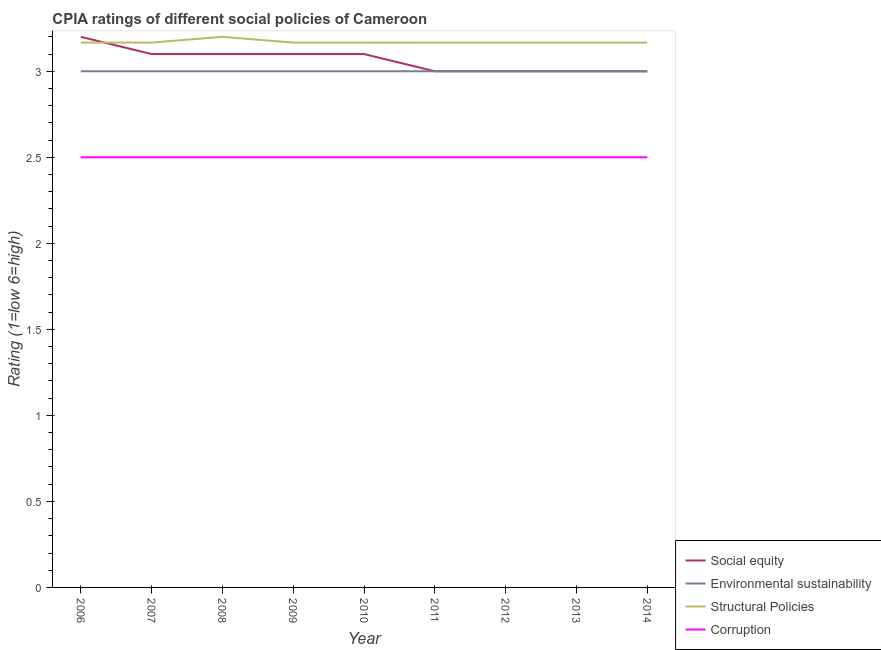How many different coloured lines are there?
Offer a very short reply. 4. Does the line corresponding to cpia rating of structural policies intersect with the line corresponding to cpia rating of environmental sustainability?
Ensure brevity in your answer.  No. What is the cpia rating of environmental sustainability in 2008?
Your response must be concise. 3. Across all years, what is the minimum cpia rating of environmental sustainability?
Your response must be concise. 3. In which year was the cpia rating of environmental sustainability minimum?
Provide a short and direct response. 2006. What is the difference between the cpia rating of environmental sustainability in 2006 and that in 2013?
Ensure brevity in your answer.  0. What is the difference between the cpia rating of social equity in 2014 and the cpia rating of environmental sustainability in 2013?
Provide a short and direct response. 0. What is the average cpia rating of social equity per year?
Your answer should be very brief. 3.07. In the year 2012, what is the difference between the cpia rating of environmental sustainability and cpia rating of corruption?
Provide a succinct answer. 0.5. What is the ratio of the cpia rating of corruption in 2007 to that in 2009?
Provide a short and direct response. 1. Is the difference between the cpia rating of environmental sustainability in 2008 and 2012 greater than the difference between the cpia rating of social equity in 2008 and 2012?
Make the answer very short. No. In how many years, is the cpia rating of environmental sustainability greater than the average cpia rating of environmental sustainability taken over all years?
Keep it short and to the point. 0. Is the sum of the cpia rating of structural policies in 2007 and 2008 greater than the maximum cpia rating of corruption across all years?
Ensure brevity in your answer.  Yes. Is it the case that in every year, the sum of the cpia rating of structural policies and cpia rating of environmental sustainability is greater than the sum of cpia rating of corruption and cpia rating of social equity?
Make the answer very short. Yes. Is it the case that in every year, the sum of the cpia rating of social equity and cpia rating of environmental sustainability is greater than the cpia rating of structural policies?
Make the answer very short. Yes. Does the cpia rating of corruption monotonically increase over the years?
Give a very brief answer. No. Is the cpia rating of environmental sustainability strictly greater than the cpia rating of structural policies over the years?
Your answer should be very brief. No. How many lines are there?
Your response must be concise. 4. Does the graph contain grids?
Your answer should be compact. No. Where does the legend appear in the graph?
Provide a succinct answer. Bottom right. What is the title of the graph?
Your response must be concise. CPIA ratings of different social policies of Cameroon. Does "Forest" appear as one of the legend labels in the graph?
Provide a short and direct response. No. What is the Rating (1=low 6=high) in Environmental sustainability in 2006?
Keep it short and to the point. 3. What is the Rating (1=low 6=high) in Structural Policies in 2006?
Give a very brief answer. 3.17. What is the Rating (1=low 6=high) in Corruption in 2006?
Make the answer very short. 2.5. What is the Rating (1=low 6=high) in Environmental sustainability in 2007?
Give a very brief answer. 3. What is the Rating (1=low 6=high) in Structural Policies in 2007?
Your response must be concise. 3.17. What is the Rating (1=low 6=high) in Corruption in 2007?
Make the answer very short. 2.5. What is the Rating (1=low 6=high) of Social equity in 2008?
Ensure brevity in your answer.  3.1. What is the Rating (1=low 6=high) in Corruption in 2008?
Your answer should be compact. 2.5. What is the Rating (1=low 6=high) in Social equity in 2009?
Give a very brief answer. 3.1. What is the Rating (1=low 6=high) of Structural Policies in 2009?
Keep it short and to the point. 3.17. What is the Rating (1=low 6=high) of Structural Policies in 2010?
Make the answer very short. 3.17. What is the Rating (1=low 6=high) of Structural Policies in 2011?
Offer a terse response. 3.17. What is the Rating (1=low 6=high) in Environmental sustainability in 2012?
Ensure brevity in your answer.  3. What is the Rating (1=low 6=high) of Structural Policies in 2012?
Make the answer very short. 3.17. What is the Rating (1=low 6=high) of Corruption in 2012?
Your answer should be very brief. 2.5. What is the Rating (1=low 6=high) of Social equity in 2013?
Provide a short and direct response. 3. What is the Rating (1=low 6=high) in Structural Policies in 2013?
Provide a short and direct response. 3.17. What is the Rating (1=low 6=high) in Corruption in 2013?
Make the answer very short. 2.5. What is the Rating (1=low 6=high) in Social equity in 2014?
Offer a very short reply. 3. What is the Rating (1=low 6=high) of Structural Policies in 2014?
Provide a short and direct response. 3.17. What is the Rating (1=low 6=high) in Corruption in 2014?
Give a very brief answer. 2.5. Across all years, what is the maximum Rating (1=low 6=high) in Environmental sustainability?
Offer a terse response. 3. Across all years, what is the minimum Rating (1=low 6=high) in Social equity?
Your answer should be very brief. 3. Across all years, what is the minimum Rating (1=low 6=high) in Environmental sustainability?
Your answer should be very brief. 3. Across all years, what is the minimum Rating (1=low 6=high) in Structural Policies?
Provide a short and direct response. 3.17. Across all years, what is the minimum Rating (1=low 6=high) of Corruption?
Make the answer very short. 2.5. What is the total Rating (1=low 6=high) of Social equity in the graph?
Ensure brevity in your answer.  27.6. What is the total Rating (1=low 6=high) in Structural Policies in the graph?
Ensure brevity in your answer.  28.53. What is the total Rating (1=low 6=high) of Corruption in the graph?
Your answer should be very brief. 22.5. What is the difference between the Rating (1=low 6=high) in Corruption in 2006 and that in 2007?
Offer a terse response. 0. What is the difference between the Rating (1=low 6=high) in Structural Policies in 2006 and that in 2008?
Provide a short and direct response. -0.03. What is the difference between the Rating (1=low 6=high) in Corruption in 2006 and that in 2008?
Ensure brevity in your answer.  0. What is the difference between the Rating (1=low 6=high) in Social equity in 2006 and that in 2009?
Your answer should be very brief. 0.1. What is the difference between the Rating (1=low 6=high) in Environmental sustainability in 2006 and that in 2009?
Offer a terse response. 0. What is the difference between the Rating (1=low 6=high) in Structural Policies in 2006 and that in 2009?
Give a very brief answer. 0. What is the difference between the Rating (1=low 6=high) in Structural Policies in 2006 and that in 2010?
Offer a very short reply. 0. What is the difference between the Rating (1=low 6=high) of Corruption in 2006 and that in 2011?
Provide a short and direct response. 0. What is the difference between the Rating (1=low 6=high) of Structural Policies in 2006 and that in 2012?
Offer a terse response. 0. What is the difference between the Rating (1=low 6=high) in Social equity in 2006 and that in 2013?
Offer a very short reply. 0.2. What is the difference between the Rating (1=low 6=high) in Structural Policies in 2006 and that in 2013?
Your answer should be compact. 0. What is the difference between the Rating (1=low 6=high) of Environmental sustainability in 2006 and that in 2014?
Offer a terse response. 0. What is the difference between the Rating (1=low 6=high) in Structural Policies in 2006 and that in 2014?
Your response must be concise. 0. What is the difference between the Rating (1=low 6=high) of Corruption in 2006 and that in 2014?
Provide a succinct answer. 0. What is the difference between the Rating (1=low 6=high) of Social equity in 2007 and that in 2008?
Provide a short and direct response. 0. What is the difference between the Rating (1=low 6=high) in Structural Policies in 2007 and that in 2008?
Give a very brief answer. -0.03. What is the difference between the Rating (1=low 6=high) in Corruption in 2007 and that in 2008?
Your answer should be compact. 0. What is the difference between the Rating (1=low 6=high) in Social equity in 2007 and that in 2009?
Provide a succinct answer. 0. What is the difference between the Rating (1=low 6=high) of Corruption in 2007 and that in 2009?
Your answer should be compact. 0. What is the difference between the Rating (1=low 6=high) of Social equity in 2007 and that in 2010?
Provide a succinct answer. 0. What is the difference between the Rating (1=low 6=high) of Structural Policies in 2007 and that in 2011?
Your answer should be very brief. 0. What is the difference between the Rating (1=low 6=high) of Corruption in 2007 and that in 2011?
Offer a terse response. 0. What is the difference between the Rating (1=low 6=high) in Social equity in 2007 and that in 2012?
Make the answer very short. 0.1. What is the difference between the Rating (1=low 6=high) of Environmental sustainability in 2007 and that in 2012?
Make the answer very short. 0. What is the difference between the Rating (1=low 6=high) of Corruption in 2007 and that in 2012?
Provide a short and direct response. 0. What is the difference between the Rating (1=low 6=high) in Social equity in 2007 and that in 2013?
Ensure brevity in your answer.  0.1. What is the difference between the Rating (1=low 6=high) in Environmental sustainability in 2007 and that in 2013?
Your answer should be compact. 0. What is the difference between the Rating (1=low 6=high) in Corruption in 2007 and that in 2013?
Keep it short and to the point. 0. What is the difference between the Rating (1=low 6=high) of Environmental sustainability in 2007 and that in 2014?
Provide a succinct answer. 0. What is the difference between the Rating (1=low 6=high) of Social equity in 2008 and that in 2009?
Keep it short and to the point. 0. What is the difference between the Rating (1=low 6=high) of Structural Policies in 2008 and that in 2009?
Offer a terse response. 0.03. What is the difference between the Rating (1=low 6=high) of Corruption in 2008 and that in 2010?
Your answer should be compact. 0. What is the difference between the Rating (1=low 6=high) in Environmental sustainability in 2008 and that in 2011?
Provide a succinct answer. 0. What is the difference between the Rating (1=low 6=high) of Social equity in 2008 and that in 2012?
Provide a short and direct response. 0.1. What is the difference between the Rating (1=low 6=high) of Environmental sustainability in 2008 and that in 2012?
Make the answer very short. 0. What is the difference between the Rating (1=low 6=high) in Corruption in 2008 and that in 2012?
Give a very brief answer. 0. What is the difference between the Rating (1=low 6=high) in Social equity in 2008 and that in 2013?
Your answer should be very brief. 0.1. What is the difference between the Rating (1=low 6=high) of Environmental sustainability in 2008 and that in 2013?
Ensure brevity in your answer.  0. What is the difference between the Rating (1=low 6=high) of Structural Policies in 2008 and that in 2013?
Give a very brief answer. 0.03. What is the difference between the Rating (1=low 6=high) of Environmental sustainability in 2008 and that in 2014?
Your answer should be compact. 0. What is the difference between the Rating (1=low 6=high) of Structural Policies in 2008 and that in 2014?
Your response must be concise. 0.03. What is the difference between the Rating (1=low 6=high) in Corruption in 2008 and that in 2014?
Your response must be concise. 0. What is the difference between the Rating (1=low 6=high) in Social equity in 2009 and that in 2010?
Your answer should be very brief. 0. What is the difference between the Rating (1=low 6=high) of Environmental sustainability in 2009 and that in 2010?
Ensure brevity in your answer.  0. What is the difference between the Rating (1=low 6=high) of Corruption in 2009 and that in 2010?
Provide a short and direct response. 0. What is the difference between the Rating (1=low 6=high) of Environmental sustainability in 2009 and that in 2011?
Your answer should be very brief. 0. What is the difference between the Rating (1=low 6=high) in Structural Policies in 2009 and that in 2011?
Give a very brief answer. 0. What is the difference between the Rating (1=low 6=high) in Corruption in 2009 and that in 2011?
Provide a succinct answer. 0. What is the difference between the Rating (1=low 6=high) of Environmental sustainability in 2009 and that in 2012?
Give a very brief answer. 0. What is the difference between the Rating (1=low 6=high) of Environmental sustainability in 2009 and that in 2013?
Provide a succinct answer. 0. What is the difference between the Rating (1=low 6=high) of Structural Policies in 2009 and that in 2013?
Offer a terse response. 0. What is the difference between the Rating (1=low 6=high) in Social equity in 2009 and that in 2014?
Make the answer very short. 0.1. What is the difference between the Rating (1=low 6=high) of Environmental sustainability in 2009 and that in 2014?
Make the answer very short. 0. What is the difference between the Rating (1=low 6=high) of Structural Policies in 2009 and that in 2014?
Provide a short and direct response. 0. What is the difference between the Rating (1=low 6=high) of Structural Policies in 2010 and that in 2011?
Offer a very short reply. 0. What is the difference between the Rating (1=low 6=high) in Social equity in 2010 and that in 2012?
Offer a terse response. 0.1. What is the difference between the Rating (1=low 6=high) in Environmental sustainability in 2010 and that in 2012?
Your answer should be very brief. 0. What is the difference between the Rating (1=low 6=high) of Structural Policies in 2010 and that in 2012?
Your answer should be very brief. 0. What is the difference between the Rating (1=low 6=high) in Corruption in 2010 and that in 2012?
Offer a very short reply. 0. What is the difference between the Rating (1=low 6=high) of Environmental sustainability in 2010 and that in 2013?
Make the answer very short. 0. What is the difference between the Rating (1=low 6=high) in Structural Policies in 2010 and that in 2013?
Offer a terse response. 0. What is the difference between the Rating (1=low 6=high) of Social equity in 2010 and that in 2014?
Ensure brevity in your answer.  0.1. What is the difference between the Rating (1=low 6=high) of Environmental sustainability in 2010 and that in 2014?
Provide a short and direct response. 0. What is the difference between the Rating (1=low 6=high) in Structural Policies in 2010 and that in 2014?
Offer a very short reply. 0. What is the difference between the Rating (1=low 6=high) of Corruption in 2010 and that in 2014?
Offer a very short reply. 0. What is the difference between the Rating (1=low 6=high) of Social equity in 2011 and that in 2012?
Keep it short and to the point. 0. What is the difference between the Rating (1=low 6=high) of Environmental sustainability in 2011 and that in 2012?
Your answer should be very brief. 0. What is the difference between the Rating (1=low 6=high) of Structural Policies in 2011 and that in 2012?
Offer a very short reply. 0. What is the difference between the Rating (1=low 6=high) in Environmental sustainability in 2011 and that in 2013?
Provide a succinct answer. 0. What is the difference between the Rating (1=low 6=high) of Corruption in 2011 and that in 2013?
Keep it short and to the point. 0. What is the difference between the Rating (1=low 6=high) of Environmental sustainability in 2011 and that in 2014?
Your answer should be very brief. 0. What is the difference between the Rating (1=low 6=high) in Corruption in 2011 and that in 2014?
Offer a terse response. 0. What is the difference between the Rating (1=low 6=high) in Environmental sustainability in 2012 and that in 2013?
Ensure brevity in your answer.  0. What is the difference between the Rating (1=low 6=high) of Corruption in 2012 and that in 2013?
Make the answer very short. 0. What is the difference between the Rating (1=low 6=high) of Social equity in 2012 and that in 2014?
Ensure brevity in your answer.  0. What is the difference between the Rating (1=low 6=high) of Structural Policies in 2012 and that in 2014?
Ensure brevity in your answer.  0. What is the difference between the Rating (1=low 6=high) in Corruption in 2012 and that in 2014?
Your response must be concise. 0. What is the difference between the Rating (1=low 6=high) of Social equity in 2013 and that in 2014?
Provide a succinct answer. 0. What is the difference between the Rating (1=low 6=high) of Environmental sustainability in 2013 and that in 2014?
Your answer should be very brief. 0. What is the difference between the Rating (1=low 6=high) in Structural Policies in 2013 and that in 2014?
Ensure brevity in your answer.  0. What is the difference between the Rating (1=low 6=high) of Environmental sustainability in 2006 and the Rating (1=low 6=high) of Structural Policies in 2007?
Offer a very short reply. -0.17. What is the difference between the Rating (1=low 6=high) of Environmental sustainability in 2006 and the Rating (1=low 6=high) of Corruption in 2007?
Ensure brevity in your answer.  0.5. What is the difference between the Rating (1=low 6=high) of Structural Policies in 2006 and the Rating (1=low 6=high) of Corruption in 2007?
Ensure brevity in your answer.  0.67. What is the difference between the Rating (1=low 6=high) of Social equity in 2006 and the Rating (1=low 6=high) of Environmental sustainability in 2008?
Make the answer very short. 0.2. What is the difference between the Rating (1=low 6=high) of Environmental sustainability in 2006 and the Rating (1=low 6=high) of Structural Policies in 2008?
Provide a succinct answer. -0.2. What is the difference between the Rating (1=low 6=high) of Environmental sustainability in 2006 and the Rating (1=low 6=high) of Corruption in 2008?
Make the answer very short. 0.5. What is the difference between the Rating (1=low 6=high) in Structural Policies in 2006 and the Rating (1=low 6=high) in Corruption in 2008?
Provide a succinct answer. 0.67. What is the difference between the Rating (1=low 6=high) of Social equity in 2006 and the Rating (1=low 6=high) of Environmental sustainability in 2009?
Offer a terse response. 0.2. What is the difference between the Rating (1=low 6=high) of Social equity in 2006 and the Rating (1=low 6=high) of Structural Policies in 2009?
Your answer should be compact. 0.03. What is the difference between the Rating (1=low 6=high) of Social equity in 2006 and the Rating (1=low 6=high) of Corruption in 2009?
Give a very brief answer. 0.7. What is the difference between the Rating (1=low 6=high) in Environmental sustainability in 2006 and the Rating (1=low 6=high) in Corruption in 2009?
Make the answer very short. 0.5. What is the difference between the Rating (1=low 6=high) of Social equity in 2006 and the Rating (1=low 6=high) of Environmental sustainability in 2010?
Your response must be concise. 0.2. What is the difference between the Rating (1=low 6=high) in Environmental sustainability in 2006 and the Rating (1=low 6=high) in Structural Policies in 2010?
Provide a succinct answer. -0.17. What is the difference between the Rating (1=low 6=high) of Environmental sustainability in 2006 and the Rating (1=low 6=high) of Corruption in 2010?
Provide a short and direct response. 0.5. What is the difference between the Rating (1=low 6=high) in Structural Policies in 2006 and the Rating (1=low 6=high) in Corruption in 2010?
Your answer should be very brief. 0.67. What is the difference between the Rating (1=low 6=high) of Social equity in 2006 and the Rating (1=low 6=high) of Structural Policies in 2011?
Keep it short and to the point. 0.03. What is the difference between the Rating (1=low 6=high) in Social equity in 2006 and the Rating (1=low 6=high) in Corruption in 2011?
Ensure brevity in your answer.  0.7. What is the difference between the Rating (1=low 6=high) in Environmental sustainability in 2006 and the Rating (1=low 6=high) in Structural Policies in 2011?
Ensure brevity in your answer.  -0.17. What is the difference between the Rating (1=low 6=high) of Environmental sustainability in 2006 and the Rating (1=low 6=high) of Corruption in 2011?
Make the answer very short. 0.5. What is the difference between the Rating (1=low 6=high) of Social equity in 2006 and the Rating (1=low 6=high) of Environmental sustainability in 2012?
Make the answer very short. 0.2. What is the difference between the Rating (1=low 6=high) in Social equity in 2006 and the Rating (1=low 6=high) in Structural Policies in 2012?
Make the answer very short. 0.03. What is the difference between the Rating (1=low 6=high) in Social equity in 2006 and the Rating (1=low 6=high) in Corruption in 2012?
Ensure brevity in your answer.  0.7. What is the difference between the Rating (1=low 6=high) of Environmental sustainability in 2006 and the Rating (1=low 6=high) of Structural Policies in 2012?
Give a very brief answer. -0.17. What is the difference between the Rating (1=low 6=high) of Structural Policies in 2006 and the Rating (1=low 6=high) of Corruption in 2012?
Provide a short and direct response. 0.67. What is the difference between the Rating (1=low 6=high) of Environmental sustainability in 2006 and the Rating (1=low 6=high) of Corruption in 2014?
Ensure brevity in your answer.  0.5. What is the difference between the Rating (1=low 6=high) in Structural Policies in 2006 and the Rating (1=low 6=high) in Corruption in 2014?
Your answer should be compact. 0.67. What is the difference between the Rating (1=low 6=high) in Social equity in 2007 and the Rating (1=low 6=high) in Environmental sustainability in 2008?
Your answer should be compact. 0.1. What is the difference between the Rating (1=low 6=high) in Social equity in 2007 and the Rating (1=low 6=high) in Corruption in 2008?
Your response must be concise. 0.6. What is the difference between the Rating (1=low 6=high) of Environmental sustainability in 2007 and the Rating (1=low 6=high) of Structural Policies in 2008?
Your answer should be compact. -0.2. What is the difference between the Rating (1=low 6=high) of Social equity in 2007 and the Rating (1=low 6=high) of Structural Policies in 2009?
Your answer should be very brief. -0.07. What is the difference between the Rating (1=low 6=high) in Environmental sustainability in 2007 and the Rating (1=low 6=high) in Structural Policies in 2009?
Give a very brief answer. -0.17. What is the difference between the Rating (1=low 6=high) of Environmental sustainability in 2007 and the Rating (1=low 6=high) of Corruption in 2009?
Your answer should be very brief. 0.5. What is the difference between the Rating (1=low 6=high) in Social equity in 2007 and the Rating (1=low 6=high) in Structural Policies in 2010?
Provide a short and direct response. -0.07. What is the difference between the Rating (1=low 6=high) in Structural Policies in 2007 and the Rating (1=low 6=high) in Corruption in 2010?
Offer a terse response. 0.67. What is the difference between the Rating (1=low 6=high) in Social equity in 2007 and the Rating (1=low 6=high) in Structural Policies in 2011?
Provide a succinct answer. -0.07. What is the difference between the Rating (1=low 6=high) of Social equity in 2007 and the Rating (1=low 6=high) of Corruption in 2011?
Offer a terse response. 0.6. What is the difference between the Rating (1=low 6=high) of Environmental sustainability in 2007 and the Rating (1=low 6=high) of Corruption in 2011?
Your response must be concise. 0.5. What is the difference between the Rating (1=low 6=high) of Social equity in 2007 and the Rating (1=low 6=high) of Structural Policies in 2012?
Provide a succinct answer. -0.07. What is the difference between the Rating (1=low 6=high) in Structural Policies in 2007 and the Rating (1=low 6=high) in Corruption in 2012?
Keep it short and to the point. 0.67. What is the difference between the Rating (1=low 6=high) in Social equity in 2007 and the Rating (1=low 6=high) in Structural Policies in 2013?
Keep it short and to the point. -0.07. What is the difference between the Rating (1=low 6=high) in Environmental sustainability in 2007 and the Rating (1=low 6=high) in Structural Policies in 2013?
Ensure brevity in your answer.  -0.17. What is the difference between the Rating (1=low 6=high) of Environmental sustainability in 2007 and the Rating (1=low 6=high) of Corruption in 2013?
Offer a terse response. 0.5. What is the difference between the Rating (1=low 6=high) in Social equity in 2007 and the Rating (1=low 6=high) in Environmental sustainability in 2014?
Ensure brevity in your answer.  0.1. What is the difference between the Rating (1=low 6=high) of Social equity in 2007 and the Rating (1=low 6=high) of Structural Policies in 2014?
Offer a terse response. -0.07. What is the difference between the Rating (1=low 6=high) in Social equity in 2007 and the Rating (1=low 6=high) in Corruption in 2014?
Provide a succinct answer. 0.6. What is the difference between the Rating (1=low 6=high) of Environmental sustainability in 2007 and the Rating (1=low 6=high) of Structural Policies in 2014?
Keep it short and to the point. -0.17. What is the difference between the Rating (1=low 6=high) of Environmental sustainability in 2007 and the Rating (1=low 6=high) of Corruption in 2014?
Your answer should be compact. 0.5. What is the difference between the Rating (1=low 6=high) of Social equity in 2008 and the Rating (1=low 6=high) of Structural Policies in 2009?
Your response must be concise. -0.07. What is the difference between the Rating (1=low 6=high) in Environmental sustainability in 2008 and the Rating (1=low 6=high) in Structural Policies in 2009?
Give a very brief answer. -0.17. What is the difference between the Rating (1=low 6=high) in Environmental sustainability in 2008 and the Rating (1=low 6=high) in Corruption in 2009?
Give a very brief answer. 0.5. What is the difference between the Rating (1=low 6=high) of Social equity in 2008 and the Rating (1=low 6=high) of Environmental sustainability in 2010?
Give a very brief answer. 0.1. What is the difference between the Rating (1=low 6=high) of Social equity in 2008 and the Rating (1=low 6=high) of Structural Policies in 2010?
Your answer should be compact. -0.07. What is the difference between the Rating (1=low 6=high) in Social equity in 2008 and the Rating (1=low 6=high) in Corruption in 2010?
Your answer should be very brief. 0.6. What is the difference between the Rating (1=low 6=high) of Environmental sustainability in 2008 and the Rating (1=low 6=high) of Structural Policies in 2010?
Provide a short and direct response. -0.17. What is the difference between the Rating (1=low 6=high) of Environmental sustainability in 2008 and the Rating (1=low 6=high) of Corruption in 2010?
Your response must be concise. 0.5. What is the difference between the Rating (1=low 6=high) of Structural Policies in 2008 and the Rating (1=low 6=high) of Corruption in 2010?
Offer a very short reply. 0.7. What is the difference between the Rating (1=low 6=high) of Social equity in 2008 and the Rating (1=low 6=high) of Environmental sustainability in 2011?
Ensure brevity in your answer.  0.1. What is the difference between the Rating (1=low 6=high) in Social equity in 2008 and the Rating (1=low 6=high) in Structural Policies in 2011?
Ensure brevity in your answer.  -0.07. What is the difference between the Rating (1=low 6=high) in Environmental sustainability in 2008 and the Rating (1=low 6=high) in Structural Policies in 2011?
Your answer should be very brief. -0.17. What is the difference between the Rating (1=low 6=high) in Social equity in 2008 and the Rating (1=low 6=high) in Environmental sustainability in 2012?
Keep it short and to the point. 0.1. What is the difference between the Rating (1=low 6=high) of Social equity in 2008 and the Rating (1=low 6=high) of Structural Policies in 2012?
Give a very brief answer. -0.07. What is the difference between the Rating (1=low 6=high) in Social equity in 2008 and the Rating (1=low 6=high) in Corruption in 2012?
Your response must be concise. 0.6. What is the difference between the Rating (1=low 6=high) of Environmental sustainability in 2008 and the Rating (1=low 6=high) of Corruption in 2012?
Your answer should be very brief. 0.5. What is the difference between the Rating (1=low 6=high) of Structural Policies in 2008 and the Rating (1=low 6=high) of Corruption in 2012?
Provide a succinct answer. 0.7. What is the difference between the Rating (1=low 6=high) in Social equity in 2008 and the Rating (1=low 6=high) in Environmental sustainability in 2013?
Your answer should be very brief. 0.1. What is the difference between the Rating (1=low 6=high) in Social equity in 2008 and the Rating (1=low 6=high) in Structural Policies in 2013?
Your answer should be very brief. -0.07. What is the difference between the Rating (1=low 6=high) of Social equity in 2008 and the Rating (1=low 6=high) of Corruption in 2013?
Provide a short and direct response. 0.6. What is the difference between the Rating (1=low 6=high) in Environmental sustainability in 2008 and the Rating (1=low 6=high) in Structural Policies in 2013?
Ensure brevity in your answer.  -0.17. What is the difference between the Rating (1=low 6=high) of Structural Policies in 2008 and the Rating (1=low 6=high) of Corruption in 2013?
Your response must be concise. 0.7. What is the difference between the Rating (1=low 6=high) in Social equity in 2008 and the Rating (1=low 6=high) in Environmental sustainability in 2014?
Make the answer very short. 0.1. What is the difference between the Rating (1=low 6=high) of Social equity in 2008 and the Rating (1=low 6=high) of Structural Policies in 2014?
Offer a very short reply. -0.07. What is the difference between the Rating (1=low 6=high) of Social equity in 2008 and the Rating (1=low 6=high) of Corruption in 2014?
Offer a very short reply. 0.6. What is the difference between the Rating (1=low 6=high) of Environmental sustainability in 2008 and the Rating (1=low 6=high) of Structural Policies in 2014?
Provide a succinct answer. -0.17. What is the difference between the Rating (1=low 6=high) of Environmental sustainability in 2008 and the Rating (1=low 6=high) of Corruption in 2014?
Make the answer very short. 0.5. What is the difference between the Rating (1=low 6=high) of Social equity in 2009 and the Rating (1=low 6=high) of Environmental sustainability in 2010?
Offer a very short reply. 0.1. What is the difference between the Rating (1=low 6=high) of Social equity in 2009 and the Rating (1=low 6=high) of Structural Policies in 2010?
Give a very brief answer. -0.07. What is the difference between the Rating (1=low 6=high) of Social equity in 2009 and the Rating (1=low 6=high) of Corruption in 2010?
Your answer should be very brief. 0.6. What is the difference between the Rating (1=low 6=high) in Environmental sustainability in 2009 and the Rating (1=low 6=high) in Corruption in 2010?
Your answer should be very brief. 0.5. What is the difference between the Rating (1=low 6=high) of Social equity in 2009 and the Rating (1=low 6=high) of Environmental sustainability in 2011?
Give a very brief answer. 0.1. What is the difference between the Rating (1=low 6=high) in Social equity in 2009 and the Rating (1=low 6=high) in Structural Policies in 2011?
Offer a terse response. -0.07. What is the difference between the Rating (1=low 6=high) of Environmental sustainability in 2009 and the Rating (1=low 6=high) of Structural Policies in 2011?
Give a very brief answer. -0.17. What is the difference between the Rating (1=low 6=high) of Social equity in 2009 and the Rating (1=low 6=high) of Environmental sustainability in 2012?
Ensure brevity in your answer.  0.1. What is the difference between the Rating (1=low 6=high) of Social equity in 2009 and the Rating (1=low 6=high) of Structural Policies in 2012?
Provide a short and direct response. -0.07. What is the difference between the Rating (1=low 6=high) in Environmental sustainability in 2009 and the Rating (1=low 6=high) in Corruption in 2012?
Give a very brief answer. 0.5. What is the difference between the Rating (1=low 6=high) of Social equity in 2009 and the Rating (1=low 6=high) of Structural Policies in 2013?
Your answer should be very brief. -0.07. What is the difference between the Rating (1=low 6=high) in Social equity in 2009 and the Rating (1=low 6=high) in Corruption in 2013?
Provide a short and direct response. 0.6. What is the difference between the Rating (1=low 6=high) of Environmental sustainability in 2009 and the Rating (1=low 6=high) of Corruption in 2013?
Keep it short and to the point. 0.5. What is the difference between the Rating (1=low 6=high) in Structural Policies in 2009 and the Rating (1=low 6=high) in Corruption in 2013?
Provide a short and direct response. 0.67. What is the difference between the Rating (1=low 6=high) in Social equity in 2009 and the Rating (1=low 6=high) in Structural Policies in 2014?
Keep it short and to the point. -0.07. What is the difference between the Rating (1=low 6=high) of Environmental sustainability in 2009 and the Rating (1=low 6=high) of Structural Policies in 2014?
Keep it short and to the point. -0.17. What is the difference between the Rating (1=low 6=high) in Structural Policies in 2009 and the Rating (1=low 6=high) in Corruption in 2014?
Provide a short and direct response. 0.67. What is the difference between the Rating (1=low 6=high) in Social equity in 2010 and the Rating (1=low 6=high) in Environmental sustainability in 2011?
Ensure brevity in your answer.  0.1. What is the difference between the Rating (1=low 6=high) of Social equity in 2010 and the Rating (1=low 6=high) of Structural Policies in 2011?
Offer a very short reply. -0.07. What is the difference between the Rating (1=low 6=high) in Social equity in 2010 and the Rating (1=low 6=high) in Corruption in 2011?
Provide a succinct answer. 0.6. What is the difference between the Rating (1=low 6=high) of Structural Policies in 2010 and the Rating (1=low 6=high) of Corruption in 2011?
Provide a succinct answer. 0.67. What is the difference between the Rating (1=low 6=high) of Social equity in 2010 and the Rating (1=low 6=high) of Structural Policies in 2012?
Offer a very short reply. -0.07. What is the difference between the Rating (1=low 6=high) in Social equity in 2010 and the Rating (1=low 6=high) in Corruption in 2012?
Give a very brief answer. 0.6. What is the difference between the Rating (1=low 6=high) of Structural Policies in 2010 and the Rating (1=low 6=high) of Corruption in 2012?
Keep it short and to the point. 0.67. What is the difference between the Rating (1=low 6=high) of Social equity in 2010 and the Rating (1=low 6=high) of Environmental sustainability in 2013?
Your response must be concise. 0.1. What is the difference between the Rating (1=low 6=high) in Social equity in 2010 and the Rating (1=low 6=high) in Structural Policies in 2013?
Provide a succinct answer. -0.07. What is the difference between the Rating (1=low 6=high) of Social equity in 2010 and the Rating (1=low 6=high) of Corruption in 2013?
Your answer should be compact. 0.6. What is the difference between the Rating (1=low 6=high) in Environmental sustainability in 2010 and the Rating (1=low 6=high) in Structural Policies in 2013?
Provide a succinct answer. -0.17. What is the difference between the Rating (1=low 6=high) in Social equity in 2010 and the Rating (1=low 6=high) in Structural Policies in 2014?
Your answer should be very brief. -0.07. What is the difference between the Rating (1=low 6=high) in Environmental sustainability in 2010 and the Rating (1=low 6=high) in Corruption in 2014?
Offer a terse response. 0.5. What is the difference between the Rating (1=low 6=high) in Structural Policies in 2010 and the Rating (1=low 6=high) in Corruption in 2014?
Keep it short and to the point. 0.67. What is the difference between the Rating (1=low 6=high) of Social equity in 2011 and the Rating (1=low 6=high) of Environmental sustainability in 2012?
Provide a short and direct response. 0. What is the difference between the Rating (1=low 6=high) in Social equity in 2011 and the Rating (1=low 6=high) in Corruption in 2012?
Offer a terse response. 0.5. What is the difference between the Rating (1=low 6=high) in Environmental sustainability in 2011 and the Rating (1=low 6=high) in Structural Policies in 2012?
Offer a very short reply. -0.17. What is the difference between the Rating (1=low 6=high) of Environmental sustainability in 2011 and the Rating (1=low 6=high) of Corruption in 2012?
Your answer should be very brief. 0.5. What is the difference between the Rating (1=low 6=high) in Social equity in 2011 and the Rating (1=low 6=high) in Environmental sustainability in 2013?
Make the answer very short. 0. What is the difference between the Rating (1=low 6=high) in Environmental sustainability in 2011 and the Rating (1=low 6=high) in Structural Policies in 2013?
Your answer should be compact. -0.17. What is the difference between the Rating (1=low 6=high) of Social equity in 2011 and the Rating (1=low 6=high) of Environmental sustainability in 2014?
Your answer should be compact. 0. What is the difference between the Rating (1=low 6=high) in Social equity in 2011 and the Rating (1=low 6=high) in Structural Policies in 2014?
Your answer should be very brief. -0.17. What is the difference between the Rating (1=low 6=high) of Social equity in 2011 and the Rating (1=low 6=high) of Corruption in 2014?
Provide a short and direct response. 0.5. What is the difference between the Rating (1=low 6=high) of Environmental sustainability in 2011 and the Rating (1=low 6=high) of Structural Policies in 2014?
Offer a terse response. -0.17. What is the difference between the Rating (1=low 6=high) in Environmental sustainability in 2011 and the Rating (1=low 6=high) in Corruption in 2014?
Give a very brief answer. 0.5. What is the difference between the Rating (1=low 6=high) of Social equity in 2012 and the Rating (1=low 6=high) of Structural Policies in 2013?
Your answer should be compact. -0.17. What is the difference between the Rating (1=low 6=high) of Environmental sustainability in 2012 and the Rating (1=low 6=high) of Structural Policies in 2013?
Make the answer very short. -0.17. What is the difference between the Rating (1=low 6=high) in Environmental sustainability in 2012 and the Rating (1=low 6=high) in Corruption in 2013?
Offer a very short reply. 0.5. What is the difference between the Rating (1=low 6=high) in Structural Policies in 2012 and the Rating (1=low 6=high) in Corruption in 2013?
Make the answer very short. 0.67. What is the difference between the Rating (1=low 6=high) in Social equity in 2012 and the Rating (1=low 6=high) in Corruption in 2014?
Provide a short and direct response. 0.5. What is the difference between the Rating (1=low 6=high) of Structural Policies in 2012 and the Rating (1=low 6=high) of Corruption in 2014?
Provide a succinct answer. 0.67. What is the difference between the Rating (1=low 6=high) in Environmental sustainability in 2013 and the Rating (1=low 6=high) in Corruption in 2014?
Your response must be concise. 0.5. What is the difference between the Rating (1=low 6=high) in Structural Policies in 2013 and the Rating (1=low 6=high) in Corruption in 2014?
Your response must be concise. 0.67. What is the average Rating (1=low 6=high) in Social equity per year?
Your answer should be very brief. 3.07. What is the average Rating (1=low 6=high) in Structural Policies per year?
Provide a short and direct response. 3.17. In the year 2006, what is the difference between the Rating (1=low 6=high) of Social equity and Rating (1=low 6=high) of Environmental sustainability?
Provide a succinct answer. 0.2. In the year 2006, what is the difference between the Rating (1=low 6=high) in Social equity and Rating (1=low 6=high) in Structural Policies?
Provide a short and direct response. 0.03. In the year 2006, what is the difference between the Rating (1=low 6=high) in Social equity and Rating (1=low 6=high) in Corruption?
Provide a short and direct response. 0.7. In the year 2006, what is the difference between the Rating (1=low 6=high) of Environmental sustainability and Rating (1=low 6=high) of Structural Policies?
Provide a succinct answer. -0.17. In the year 2007, what is the difference between the Rating (1=low 6=high) in Social equity and Rating (1=low 6=high) in Environmental sustainability?
Provide a short and direct response. 0.1. In the year 2007, what is the difference between the Rating (1=low 6=high) of Social equity and Rating (1=low 6=high) of Structural Policies?
Your answer should be compact. -0.07. In the year 2007, what is the difference between the Rating (1=low 6=high) of Social equity and Rating (1=low 6=high) of Corruption?
Provide a succinct answer. 0.6. In the year 2007, what is the difference between the Rating (1=low 6=high) of Environmental sustainability and Rating (1=low 6=high) of Structural Policies?
Provide a short and direct response. -0.17. In the year 2008, what is the difference between the Rating (1=low 6=high) of Social equity and Rating (1=low 6=high) of Environmental sustainability?
Your answer should be compact. 0.1. In the year 2008, what is the difference between the Rating (1=low 6=high) in Environmental sustainability and Rating (1=low 6=high) in Structural Policies?
Offer a terse response. -0.2. In the year 2008, what is the difference between the Rating (1=low 6=high) in Environmental sustainability and Rating (1=low 6=high) in Corruption?
Keep it short and to the point. 0.5. In the year 2008, what is the difference between the Rating (1=low 6=high) of Structural Policies and Rating (1=low 6=high) of Corruption?
Your answer should be very brief. 0.7. In the year 2009, what is the difference between the Rating (1=low 6=high) in Social equity and Rating (1=low 6=high) in Environmental sustainability?
Keep it short and to the point. 0.1. In the year 2009, what is the difference between the Rating (1=low 6=high) in Social equity and Rating (1=low 6=high) in Structural Policies?
Make the answer very short. -0.07. In the year 2009, what is the difference between the Rating (1=low 6=high) in Social equity and Rating (1=low 6=high) in Corruption?
Offer a terse response. 0.6. In the year 2009, what is the difference between the Rating (1=low 6=high) in Environmental sustainability and Rating (1=low 6=high) in Structural Policies?
Your response must be concise. -0.17. In the year 2009, what is the difference between the Rating (1=low 6=high) of Structural Policies and Rating (1=low 6=high) of Corruption?
Your answer should be very brief. 0.67. In the year 2010, what is the difference between the Rating (1=low 6=high) in Social equity and Rating (1=low 6=high) in Structural Policies?
Your answer should be very brief. -0.07. In the year 2010, what is the difference between the Rating (1=low 6=high) in Social equity and Rating (1=low 6=high) in Corruption?
Your response must be concise. 0.6. In the year 2010, what is the difference between the Rating (1=low 6=high) of Structural Policies and Rating (1=low 6=high) of Corruption?
Offer a very short reply. 0.67. In the year 2011, what is the difference between the Rating (1=low 6=high) in Social equity and Rating (1=low 6=high) in Corruption?
Your response must be concise. 0.5. In the year 2011, what is the difference between the Rating (1=low 6=high) of Environmental sustainability and Rating (1=low 6=high) of Structural Policies?
Your answer should be compact. -0.17. In the year 2011, what is the difference between the Rating (1=low 6=high) of Environmental sustainability and Rating (1=low 6=high) of Corruption?
Offer a terse response. 0.5. In the year 2012, what is the difference between the Rating (1=low 6=high) of Social equity and Rating (1=low 6=high) of Environmental sustainability?
Your answer should be compact. 0. In the year 2012, what is the difference between the Rating (1=low 6=high) in Social equity and Rating (1=low 6=high) in Structural Policies?
Make the answer very short. -0.17. In the year 2012, what is the difference between the Rating (1=low 6=high) in Social equity and Rating (1=low 6=high) in Corruption?
Your response must be concise. 0.5. In the year 2012, what is the difference between the Rating (1=low 6=high) in Environmental sustainability and Rating (1=low 6=high) in Corruption?
Ensure brevity in your answer.  0.5. In the year 2012, what is the difference between the Rating (1=low 6=high) in Structural Policies and Rating (1=low 6=high) in Corruption?
Provide a short and direct response. 0.67. In the year 2013, what is the difference between the Rating (1=low 6=high) in Social equity and Rating (1=low 6=high) in Environmental sustainability?
Make the answer very short. 0. In the year 2013, what is the difference between the Rating (1=low 6=high) of Social equity and Rating (1=low 6=high) of Structural Policies?
Provide a succinct answer. -0.17. In the year 2013, what is the difference between the Rating (1=low 6=high) in Social equity and Rating (1=low 6=high) in Corruption?
Keep it short and to the point. 0.5. In the year 2013, what is the difference between the Rating (1=low 6=high) in Environmental sustainability and Rating (1=low 6=high) in Corruption?
Make the answer very short. 0.5. In the year 2014, what is the difference between the Rating (1=low 6=high) in Social equity and Rating (1=low 6=high) in Structural Policies?
Ensure brevity in your answer.  -0.17. In the year 2014, what is the difference between the Rating (1=low 6=high) in Environmental sustainability and Rating (1=low 6=high) in Structural Policies?
Provide a short and direct response. -0.17. In the year 2014, what is the difference between the Rating (1=low 6=high) of Structural Policies and Rating (1=low 6=high) of Corruption?
Give a very brief answer. 0.67. What is the ratio of the Rating (1=low 6=high) of Social equity in 2006 to that in 2007?
Provide a succinct answer. 1.03. What is the ratio of the Rating (1=low 6=high) of Environmental sustainability in 2006 to that in 2007?
Provide a short and direct response. 1. What is the ratio of the Rating (1=low 6=high) of Structural Policies in 2006 to that in 2007?
Your answer should be very brief. 1. What is the ratio of the Rating (1=low 6=high) of Social equity in 2006 to that in 2008?
Your response must be concise. 1.03. What is the ratio of the Rating (1=low 6=high) in Social equity in 2006 to that in 2009?
Provide a succinct answer. 1.03. What is the ratio of the Rating (1=low 6=high) in Structural Policies in 2006 to that in 2009?
Your response must be concise. 1. What is the ratio of the Rating (1=low 6=high) of Social equity in 2006 to that in 2010?
Your answer should be compact. 1.03. What is the ratio of the Rating (1=low 6=high) in Environmental sustainability in 2006 to that in 2010?
Make the answer very short. 1. What is the ratio of the Rating (1=low 6=high) in Structural Policies in 2006 to that in 2010?
Ensure brevity in your answer.  1. What is the ratio of the Rating (1=low 6=high) in Social equity in 2006 to that in 2011?
Keep it short and to the point. 1.07. What is the ratio of the Rating (1=low 6=high) in Environmental sustainability in 2006 to that in 2011?
Your answer should be compact. 1. What is the ratio of the Rating (1=low 6=high) of Structural Policies in 2006 to that in 2011?
Ensure brevity in your answer.  1. What is the ratio of the Rating (1=low 6=high) in Corruption in 2006 to that in 2011?
Provide a succinct answer. 1. What is the ratio of the Rating (1=low 6=high) of Social equity in 2006 to that in 2012?
Your response must be concise. 1.07. What is the ratio of the Rating (1=low 6=high) of Structural Policies in 2006 to that in 2012?
Offer a very short reply. 1. What is the ratio of the Rating (1=low 6=high) in Social equity in 2006 to that in 2013?
Offer a very short reply. 1.07. What is the ratio of the Rating (1=low 6=high) in Structural Policies in 2006 to that in 2013?
Offer a terse response. 1. What is the ratio of the Rating (1=low 6=high) in Social equity in 2006 to that in 2014?
Provide a short and direct response. 1.07. What is the ratio of the Rating (1=low 6=high) of Structural Policies in 2006 to that in 2014?
Ensure brevity in your answer.  1. What is the ratio of the Rating (1=low 6=high) in Social equity in 2007 to that in 2008?
Your response must be concise. 1. What is the ratio of the Rating (1=low 6=high) of Environmental sustainability in 2007 to that in 2008?
Make the answer very short. 1. What is the ratio of the Rating (1=low 6=high) in Structural Policies in 2007 to that in 2008?
Give a very brief answer. 0.99. What is the ratio of the Rating (1=low 6=high) in Structural Policies in 2007 to that in 2009?
Make the answer very short. 1. What is the ratio of the Rating (1=low 6=high) of Corruption in 2007 to that in 2009?
Ensure brevity in your answer.  1. What is the ratio of the Rating (1=low 6=high) in Social equity in 2007 to that in 2010?
Make the answer very short. 1. What is the ratio of the Rating (1=low 6=high) of Environmental sustainability in 2007 to that in 2010?
Your answer should be very brief. 1. What is the ratio of the Rating (1=low 6=high) in Corruption in 2007 to that in 2010?
Your answer should be very brief. 1. What is the ratio of the Rating (1=low 6=high) of Environmental sustainability in 2007 to that in 2011?
Your response must be concise. 1. What is the ratio of the Rating (1=low 6=high) in Social equity in 2007 to that in 2012?
Provide a succinct answer. 1.03. What is the ratio of the Rating (1=low 6=high) in Environmental sustainability in 2007 to that in 2012?
Offer a terse response. 1. What is the ratio of the Rating (1=low 6=high) in Social equity in 2007 to that in 2013?
Make the answer very short. 1.03. What is the ratio of the Rating (1=low 6=high) in Corruption in 2007 to that in 2013?
Provide a short and direct response. 1. What is the ratio of the Rating (1=low 6=high) in Environmental sustainability in 2007 to that in 2014?
Give a very brief answer. 1. What is the ratio of the Rating (1=low 6=high) of Corruption in 2007 to that in 2014?
Your response must be concise. 1. What is the ratio of the Rating (1=low 6=high) of Structural Policies in 2008 to that in 2009?
Your answer should be very brief. 1.01. What is the ratio of the Rating (1=low 6=high) in Corruption in 2008 to that in 2009?
Provide a succinct answer. 1. What is the ratio of the Rating (1=low 6=high) in Structural Policies in 2008 to that in 2010?
Provide a short and direct response. 1.01. What is the ratio of the Rating (1=low 6=high) in Environmental sustainability in 2008 to that in 2011?
Ensure brevity in your answer.  1. What is the ratio of the Rating (1=low 6=high) of Structural Policies in 2008 to that in 2011?
Make the answer very short. 1.01. What is the ratio of the Rating (1=low 6=high) of Structural Policies in 2008 to that in 2012?
Keep it short and to the point. 1.01. What is the ratio of the Rating (1=low 6=high) of Social equity in 2008 to that in 2013?
Offer a terse response. 1.03. What is the ratio of the Rating (1=low 6=high) in Structural Policies in 2008 to that in 2013?
Provide a succinct answer. 1.01. What is the ratio of the Rating (1=low 6=high) in Environmental sustainability in 2008 to that in 2014?
Provide a short and direct response. 1. What is the ratio of the Rating (1=low 6=high) in Structural Policies in 2008 to that in 2014?
Your response must be concise. 1.01. What is the ratio of the Rating (1=low 6=high) of Corruption in 2008 to that in 2014?
Offer a very short reply. 1. What is the ratio of the Rating (1=low 6=high) in Environmental sustainability in 2009 to that in 2010?
Give a very brief answer. 1. What is the ratio of the Rating (1=low 6=high) in Social equity in 2009 to that in 2011?
Provide a succinct answer. 1.03. What is the ratio of the Rating (1=low 6=high) in Structural Policies in 2009 to that in 2011?
Offer a very short reply. 1. What is the ratio of the Rating (1=low 6=high) in Corruption in 2009 to that in 2011?
Offer a terse response. 1. What is the ratio of the Rating (1=low 6=high) of Environmental sustainability in 2009 to that in 2012?
Provide a succinct answer. 1. What is the ratio of the Rating (1=low 6=high) of Corruption in 2009 to that in 2012?
Your answer should be compact. 1. What is the ratio of the Rating (1=low 6=high) in Structural Policies in 2009 to that in 2013?
Provide a short and direct response. 1. What is the ratio of the Rating (1=low 6=high) of Social equity in 2009 to that in 2014?
Provide a short and direct response. 1.03. What is the ratio of the Rating (1=low 6=high) of Environmental sustainability in 2009 to that in 2014?
Your answer should be very brief. 1. What is the ratio of the Rating (1=low 6=high) in Social equity in 2010 to that in 2011?
Provide a succinct answer. 1.03. What is the ratio of the Rating (1=low 6=high) of Structural Policies in 2010 to that in 2011?
Your answer should be compact. 1. What is the ratio of the Rating (1=low 6=high) of Corruption in 2010 to that in 2011?
Provide a succinct answer. 1. What is the ratio of the Rating (1=low 6=high) in Social equity in 2010 to that in 2012?
Make the answer very short. 1.03. What is the ratio of the Rating (1=low 6=high) of Environmental sustainability in 2010 to that in 2012?
Ensure brevity in your answer.  1. What is the ratio of the Rating (1=low 6=high) in Social equity in 2010 to that in 2013?
Your response must be concise. 1.03. What is the ratio of the Rating (1=low 6=high) of Structural Policies in 2010 to that in 2013?
Offer a terse response. 1. What is the ratio of the Rating (1=low 6=high) in Corruption in 2010 to that in 2014?
Make the answer very short. 1. What is the ratio of the Rating (1=low 6=high) of Social equity in 2011 to that in 2012?
Give a very brief answer. 1. What is the ratio of the Rating (1=low 6=high) of Structural Policies in 2011 to that in 2012?
Provide a succinct answer. 1. What is the ratio of the Rating (1=low 6=high) in Environmental sustainability in 2011 to that in 2013?
Make the answer very short. 1. What is the ratio of the Rating (1=low 6=high) in Structural Policies in 2011 to that in 2013?
Your answer should be very brief. 1. What is the ratio of the Rating (1=low 6=high) in Corruption in 2011 to that in 2013?
Provide a succinct answer. 1. What is the ratio of the Rating (1=low 6=high) in Social equity in 2011 to that in 2014?
Provide a succinct answer. 1. What is the ratio of the Rating (1=low 6=high) in Environmental sustainability in 2011 to that in 2014?
Your answer should be compact. 1. What is the ratio of the Rating (1=low 6=high) in Structural Policies in 2012 to that in 2013?
Your answer should be very brief. 1. What is the ratio of the Rating (1=low 6=high) in Corruption in 2012 to that in 2013?
Your response must be concise. 1. What is the ratio of the Rating (1=low 6=high) in Structural Policies in 2013 to that in 2014?
Offer a terse response. 1. What is the difference between the highest and the second highest Rating (1=low 6=high) of Corruption?
Your response must be concise. 0. What is the difference between the highest and the lowest Rating (1=low 6=high) in Environmental sustainability?
Offer a very short reply. 0. 